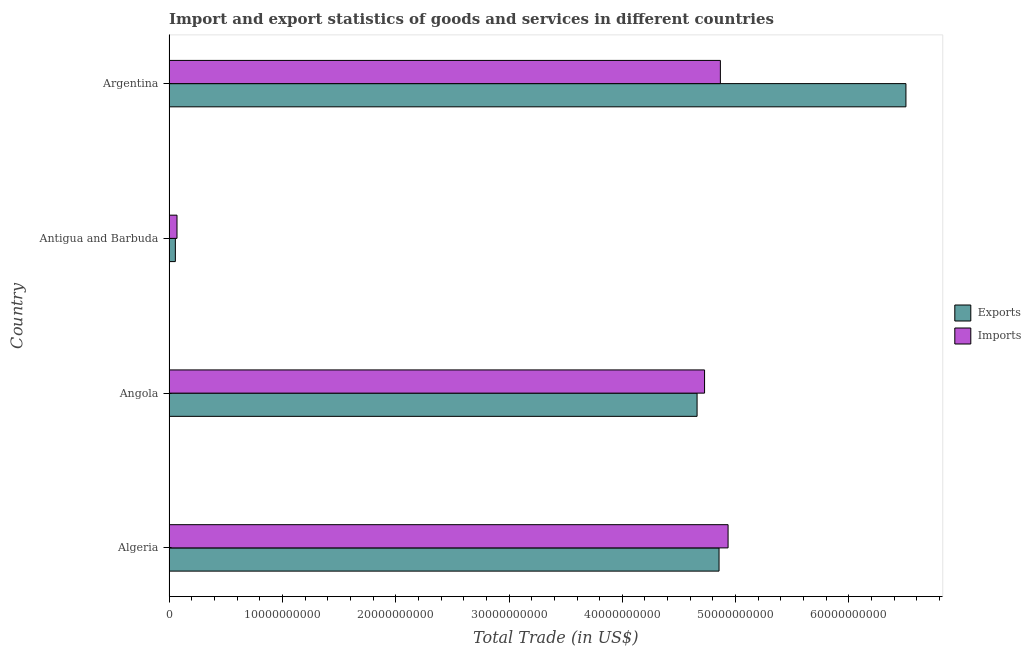How many different coloured bars are there?
Your answer should be very brief. 2. How many groups of bars are there?
Make the answer very short. 4. Are the number of bars on each tick of the Y-axis equal?
Ensure brevity in your answer.  Yes. How many bars are there on the 4th tick from the top?
Provide a succinct answer. 2. What is the label of the 3rd group of bars from the top?
Keep it short and to the point. Angola. What is the imports of goods and services in Argentina?
Your answer should be compact. 4.87e+1. Across all countries, what is the maximum export of goods and services?
Give a very brief answer. 6.50e+1. Across all countries, what is the minimum export of goods and services?
Offer a very short reply. 5.62e+08. In which country was the imports of goods and services maximum?
Keep it short and to the point. Algeria. In which country was the export of goods and services minimum?
Keep it short and to the point. Antigua and Barbuda. What is the total export of goods and services in the graph?
Offer a terse response. 1.61e+11. What is the difference between the export of goods and services in Algeria and that in Antigua and Barbuda?
Your answer should be compact. 4.80e+1. What is the difference between the export of goods and services in Angola and the imports of goods and services in Argentina?
Your response must be concise. -2.06e+09. What is the average imports of goods and services per country?
Ensure brevity in your answer.  3.65e+1. What is the difference between the imports of goods and services and export of goods and services in Algeria?
Offer a very short reply. 7.97e+08. In how many countries, is the export of goods and services greater than 64000000000 US$?
Your response must be concise. 1. What is the ratio of the export of goods and services in Angola to that in Antigua and Barbuda?
Offer a terse response. 82.97. What is the difference between the highest and the second highest export of goods and services?
Your response must be concise. 1.65e+1. What is the difference between the highest and the lowest export of goods and services?
Make the answer very short. 6.45e+1. In how many countries, is the export of goods and services greater than the average export of goods and services taken over all countries?
Make the answer very short. 3. What does the 1st bar from the top in Angola represents?
Provide a succinct answer. Imports. What does the 2nd bar from the bottom in Antigua and Barbuda represents?
Make the answer very short. Imports. How many bars are there?
Give a very brief answer. 8. What is the difference between two consecutive major ticks on the X-axis?
Give a very brief answer. 1.00e+1. Are the values on the major ticks of X-axis written in scientific E-notation?
Offer a very short reply. No. Where does the legend appear in the graph?
Keep it short and to the point. Center right. How are the legend labels stacked?
Offer a terse response. Vertical. What is the title of the graph?
Your answer should be compact. Import and export statistics of goods and services in different countries. Does "Services" appear as one of the legend labels in the graph?
Your answer should be compact. No. What is the label or title of the X-axis?
Offer a terse response. Total Trade (in US$). What is the label or title of the Y-axis?
Your answer should be very brief. Country. What is the Total Trade (in US$) in Exports in Algeria?
Provide a succinct answer. 4.85e+1. What is the Total Trade (in US$) in Imports in Algeria?
Offer a very short reply. 4.93e+1. What is the Total Trade (in US$) of Exports in Angola?
Provide a succinct answer. 4.66e+1. What is the Total Trade (in US$) in Imports in Angola?
Your answer should be very brief. 4.73e+1. What is the Total Trade (in US$) of Exports in Antigua and Barbuda?
Make the answer very short. 5.62e+08. What is the Total Trade (in US$) of Imports in Antigua and Barbuda?
Offer a very short reply. 7.06e+08. What is the Total Trade (in US$) in Exports in Argentina?
Your answer should be compact. 6.50e+1. What is the Total Trade (in US$) of Imports in Argentina?
Provide a short and direct response. 4.87e+1. Across all countries, what is the maximum Total Trade (in US$) in Exports?
Your response must be concise. 6.50e+1. Across all countries, what is the maximum Total Trade (in US$) of Imports?
Your response must be concise. 4.93e+1. Across all countries, what is the minimum Total Trade (in US$) in Exports?
Keep it short and to the point. 5.62e+08. Across all countries, what is the minimum Total Trade (in US$) in Imports?
Offer a terse response. 7.06e+08. What is the total Total Trade (in US$) of Exports in the graph?
Make the answer very short. 1.61e+11. What is the total Total Trade (in US$) of Imports in the graph?
Offer a terse response. 1.46e+11. What is the difference between the Total Trade (in US$) in Exports in Algeria and that in Angola?
Make the answer very short. 1.94e+09. What is the difference between the Total Trade (in US$) in Imports in Algeria and that in Angola?
Give a very brief answer. 2.07e+09. What is the difference between the Total Trade (in US$) in Exports in Algeria and that in Antigua and Barbuda?
Offer a terse response. 4.80e+1. What is the difference between the Total Trade (in US$) of Imports in Algeria and that in Antigua and Barbuda?
Keep it short and to the point. 4.86e+1. What is the difference between the Total Trade (in US$) in Exports in Algeria and that in Argentina?
Keep it short and to the point. -1.65e+1. What is the difference between the Total Trade (in US$) of Imports in Algeria and that in Argentina?
Your response must be concise. 6.79e+08. What is the difference between the Total Trade (in US$) in Exports in Angola and that in Antigua and Barbuda?
Keep it short and to the point. 4.60e+1. What is the difference between the Total Trade (in US$) of Imports in Angola and that in Antigua and Barbuda?
Offer a very short reply. 4.66e+1. What is the difference between the Total Trade (in US$) of Exports in Angola and that in Argentina?
Your answer should be very brief. -1.84e+1. What is the difference between the Total Trade (in US$) of Imports in Angola and that in Argentina?
Provide a short and direct response. -1.39e+09. What is the difference between the Total Trade (in US$) in Exports in Antigua and Barbuda and that in Argentina?
Your response must be concise. -6.45e+1. What is the difference between the Total Trade (in US$) in Imports in Antigua and Barbuda and that in Argentina?
Your answer should be compact. -4.79e+1. What is the difference between the Total Trade (in US$) of Exports in Algeria and the Total Trade (in US$) of Imports in Angola?
Ensure brevity in your answer.  1.28e+09. What is the difference between the Total Trade (in US$) in Exports in Algeria and the Total Trade (in US$) in Imports in Antigua and Barbuda?
Your answer should be compact. 4.78e+1. What is the difference between the Total Trade (in US$) of Exports in Algeria and the Total Trade (in US$) of Imports in Argentina?
Provide a short and direct response. -1.18e+08. What is the difference between the Total Trade (in US$) in Exports in Angola and the Total Trade (in US$) in Imports in Antigua and Barbuda?
Offer a very short reply. 4.59e+1. What is the difference between the Total Trade (in US$) in Exports in Angola and the Total Trade (in US$) in Imports in Argentina?
Offer a terse response. -2.06e+09. What is the difference between the Total Trade (in US$) of Exports in Antigua and Barbuda and the Total Trade (in US$) of Imports in Argentina?
Your answer should be compact. -4.81e+1. What is the average Total Trade (in US$) of Exports per country?
Make the answer very short. 4.02e+1. What is the average Total Trade (in US$) of Imports per country?
Ensure brevity in your answer.  3.65e+1. What is the difference between the Total Trade (in US$) in Exports and Total Trade (in US$) in Imports in Algeria?
Offer a terse response. -7.97e+08. What is the difference between the Total Trade (in US$) of Exports and Total Trade (in US$) of Imports in Angola?
Provide a succinct answer. -6.60e+08. What is the difference between the Total Trade (in US$) in Exports and Total Trade (in US$) in Imports in Antigua and Barbuda?
Offer a terse response. -1.45e+08. What is the difference between the Total Trade (in US$) in Exports and Total Trade (in US$) in Imports in Argentina?
Provide a short and direct response. 1.64e+1. What is the ratio of the Total Trade (in US$) in Exports in Algeria to that in Angola?
Offer a very short reply. 1.04. What is the ratio of the Total Trade (in US$) of Imports in Algeria to that in Angola?
Your answer should be very brief. 1.04. What is the ratio of the Total Trade (in US$) of Exports in Algeria to that in Antigua and Barbuda?
Your answer should be compact. 86.42. What is the ratio of the Total Trade (in US$) in Imports in Algeria to that in Antigua and Barbuda?
Keep it short and to the point. 69.83. What is the ratio of the Total Trade (in US$) in Exports in Algeria to that in Argentina?
Ensure brevity in your answer.  0.75. What is the ratio of the Total Trade (in US$) of Imports in Algeria to that in Argentina?
Ensure brevity in your answer.  1.01. What is the ratio of the Total Trade (in US$) of Exports in Angola to that in Antigua and Barbuda?
Provide a succinct answer. 82.97. What is the ratio of the Total Trade (in US$) in Imports in Angola to that in Antigua and Barbuda?
Your answer should be very brief. 66.89. What is the ratio of the Total Trade (in US$) of Exports in Angola to that in Argentina?
Offer a very short reply. 0.72. What is the ratio of the Total Trade (in US$) of Imports in Angola to that in Argentina?
Keep it short and to the point. 0.97. What is the ratio of the Total Trade (in US$) in Exports in Antigua and Barbuda to that in Argentina?
Offer a terse response. 0.01. What is the ratio of the Total Trade (in US$) in Imports in Antigua and Barbuda to that in Argentina?
Your answer should be very brief. 0.01. What is the difference between the highest and the second highest Total Trade (in US$) of Exports?
Ensure brevity in your answer.  1.65e+1. What is the difference between the highest and the second highest Total Trade (in US$) of Imports?
Ensure brevity in your answer.  6.79e+08. What is the difference between the highest and the lowest Total Trade (in US$) of Exports?
Offer a very short reply. 6.45e+1. What is the difference between the highest and the lowest Total Trade (in US$) of Imports?
Provide a short and direct response. 4.86e+1. 